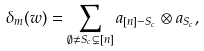Convert formula to latex. <formula><loc_0><loc_0><loc_500><loc_500>\delta _ { m } ( w ) = \sum _ { \emptyset \neq S _ { c } \subsetneq [ n ] } a _ { [ n ] - S _ { c } } \otimes a _ { S _ { c } } ,</formula> 